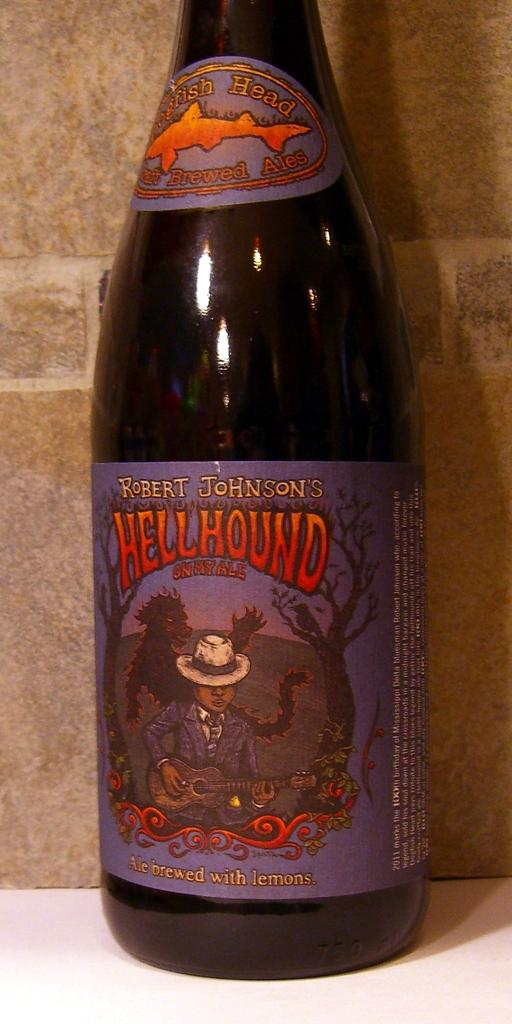<image>
Create a compact narrative representing the image presented. A hell Hound beer brand is sitting on a table 